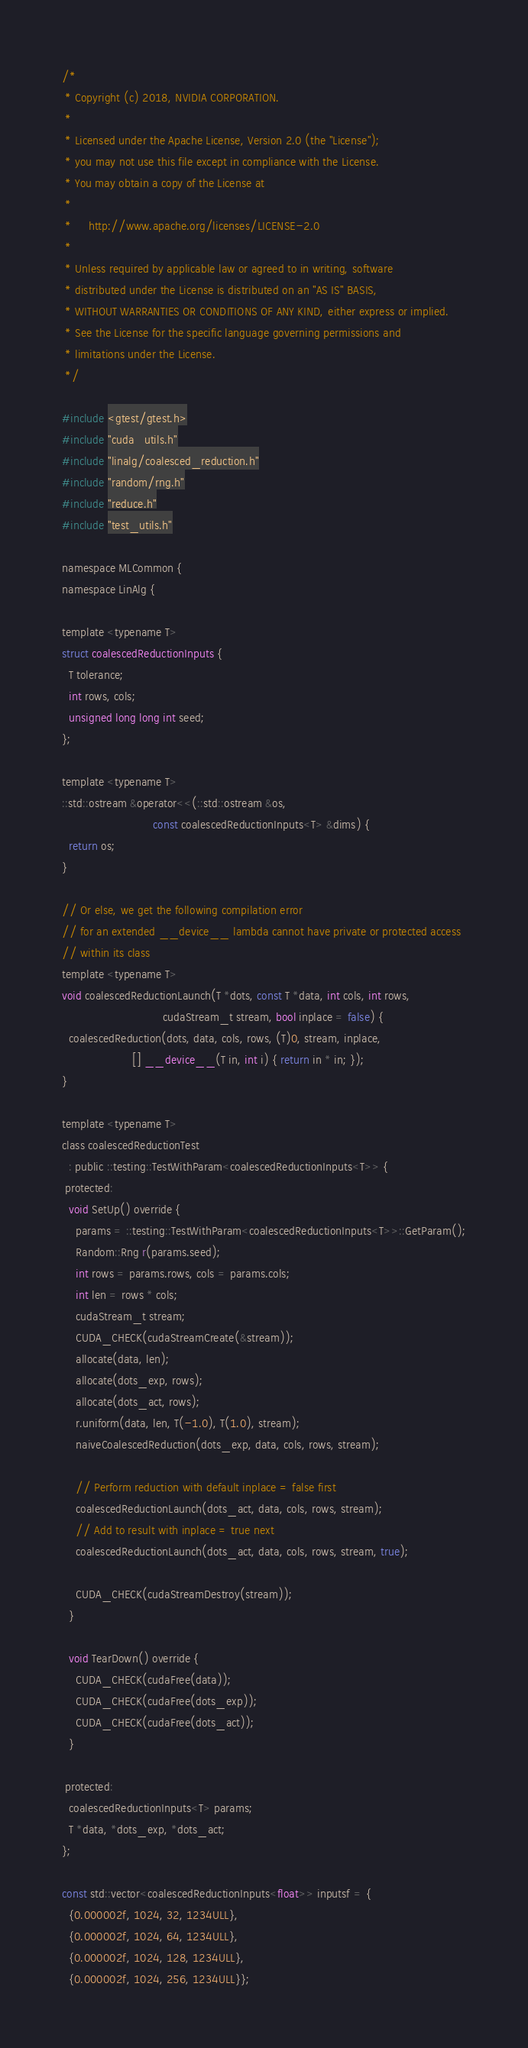<code> <loc_0><loc_0><loc_500><loc_500><_Cuda_>/*
 * Copyright (c) 2018, NVIDIA CORPORATION.
 *
 * Licensed under the Apache License, Version 2.0 (the "License");
 * you may not use this file except in compliance with the License.
 * You may obtain a copy of the License at
 *
 *     http://www.apache.org/licenses/LICENSE-2.0
 *
 * Unless required by applicable law or agreed to in writing, software
 * distributed under the License is distributed on an "AS IS" BASIS,
 * WITHOUT WARRANTIES OR CONDITIONS OF ANY KIND, either express or implied.
 * See the License for the specific language governing permissions and
 * limitations under the License.
 */

#include <gtest/gtest.h>
#include "cuda_utils.h"
#include "linalg/coalesced_reduction.h"
#include "random/rng.h"
#include "reduce.h"
#include "test_utils.h"

namespace MLCommon {
namespace LinAlg {

template <typename T>
struct coalescedReductionInputs {
  T tolerance;
  int rows, cols;
  unsigned long long int seed;
};

template <typename T>
::std::ostream &operator<<(::std::ostream &os,
                           const coalescedReductionInputs<T> &dims) {
  return os;
}

// Or else, we get the following compilation error
// for an extended __device__ lambda cannot have private or protected access
// within its class
template <typename T>
void coalescedReductionLaunch(T *dots, const T *data, int cols, int rows,
                              cudaStream_t stream, bool inplace = false) {
  coalescedReduction(dots, data, cols, rows, (T)0, stream, inplace,
                     [] __device__(T in, int i) { return in * in; });
}

template <typename T>
class coalescedReductionTest
  : public ::testing::TestWithParam<coalescedReductionInputs<T>> {
 protected:
  void SetUp() override {
    params = ::testing::TestWithParam<coalescedReductionInputs<T>>::GetParam();
    Random::Rng r(params.seed);
    int rows = params.rows, cols = params.cols;
    int len = rows * cols;
    cudaStream_t stream;
    CUDA_CHECK(cudaStreamCreate(&stream));
    allocate(data, len);
    allocate(dots_exp, rows);
    allocate(dots_act, rows);
    r.uniform(data, len, T(-1.0), T(1.0), stream);
    naiveCoalescedReduction(dots_exp, data, cols, rows, stream);

    // Perform reduction with default inplace = false first
    coalescedReductionLaunch(dots_act, data, cols, rows, stream);
    // Add to result with inplace = true next
    coalescedReductionLaunch(dots_act, data, cols, rows, stream, true);

    CUDA_CHECK(cudaStreamDestroy(stream));
  }

  void TearDown() override {
    CUDA_CHECK(cudaFree(data));
    CUDA_CHECK(cudaFree(dots_exp));
    CUDA_CHECK(cudaFree(dots_act));
  }

 protected:
  coalescedReductionInputs<T> params;
  T *data, *dots_exp, *dots_act;
};

const std::vector<coalescedReductionInputs<float>> inputsf = {
  {0.000002f, 1024, 32, 1234ULL},
  {0.000002f, 1024, 64, 1234ULL},
  {0.000002f, 1024, 128, 1234ULL},
  {0.000002f, 1024, 256, 1234ULL}};
</code> 